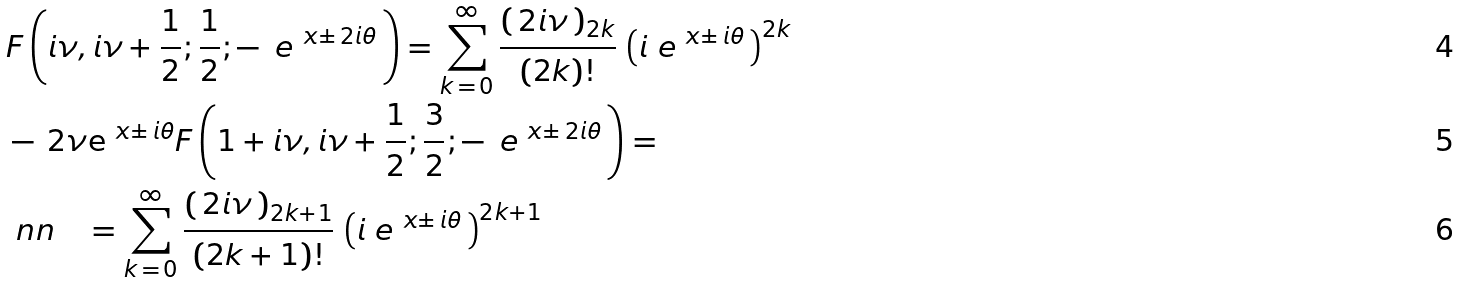<formula> <loc_0><loc_0><loc_500><loc_500>& F \left ( { i \nu } , i \nu + { \frac { 1 } { 2 } } ; { \frac { 1 } { 2 } } ; - \, \ e ^ { \ x \pm \, 2 i \theta } \, \right ) = \sum _ { k \, = \, 0 } ^ { \infty } \frac { \left ( \, 2 i \nu \, \right ) _ { 2 k } } { ( 2 k ) ! } \, \left ( i \ e ^ { \ x \pm \, i \theta } \, \right ) ^ { 2 k } \\ & - \, 2 \nu \mathrm e ^ { \ x \pm \, i \theta } F \left ( 1 + i \nu , i \nu + { \frac { 1 } { 2 } } ; { \frac { 3 } { 2 } } ; - \, \ e ^ { \ x \pm \, 2 i \theta } \, \right ) = \\ & \ n n \quad = \sum _ { k \, = \, 0 } ^ { \infty } \frac { \left ( \, 2 i \nu \, \right ) _ { 2 k + 1 } } { ( 2 k + 1 ) ! } \, \left ( i \ e ^ { \ x \pm \, i \theta } \, \right ) ^ { 2 k + 1 }</formula> 